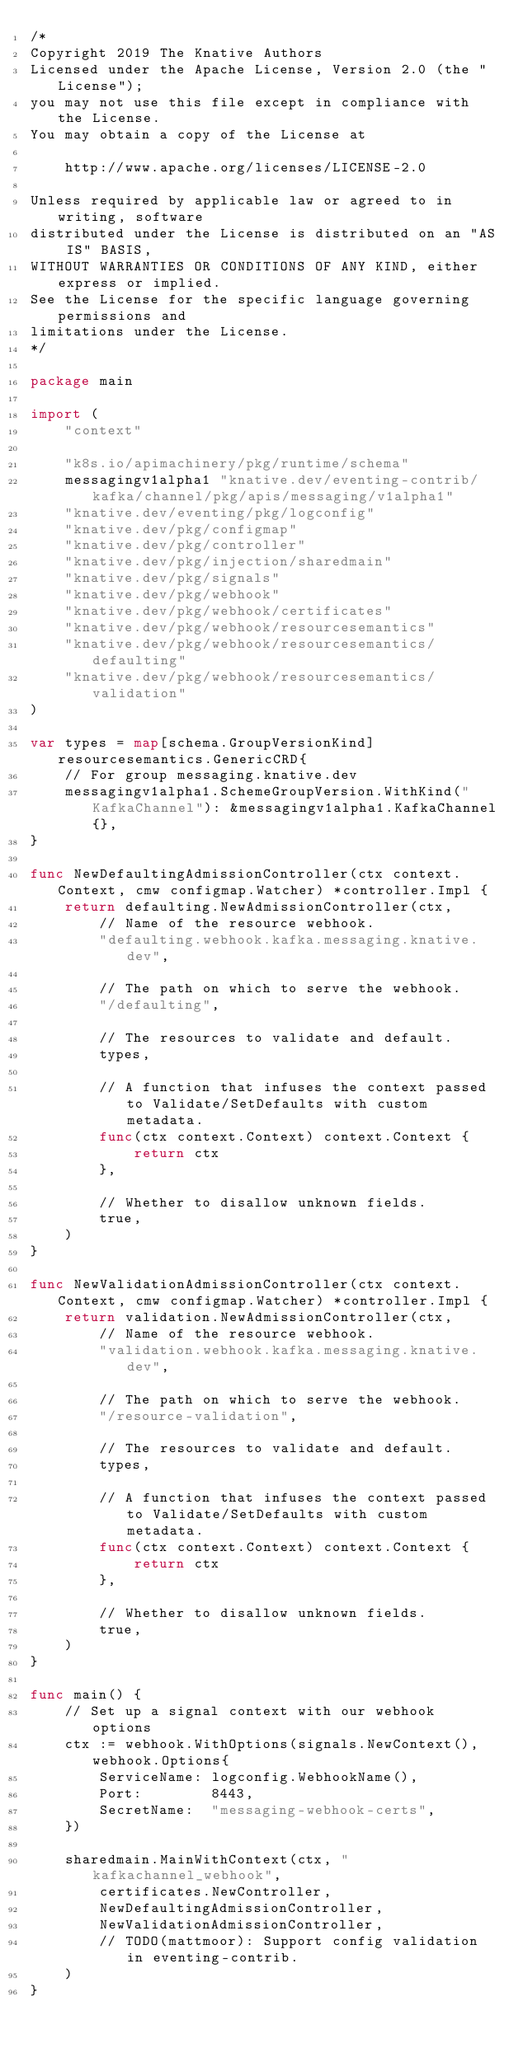Convert code to text. <code><loc_0><loc_0><loc_500><loc_500><_Go_>/*
Copyright 2019 The Knative Authors
Licensed under the Apache License, Version 2.0 (the "License");
you may not use this file except in compliance with the License.
You may obtain a copy of the License at

    http://www.apache.org/licenses/LICENSE-2.0

Unless required by applicable law or agreed to in writing, software
distributed under the License is distributed on an "AS IS" BASIS,
WITHOUT WARRANTIES OR CONDITIONS OF ANY KIND, either express or implied.
See the License for the specific language governing permissions and
limitations under the License.
*/

package main

import (
	"context"

	"k8s.io/apimachinery/pkg/runtime/schema"
	messagingv1alpha1 "knative.dev/eventing-contrib/kafka/channel/pkg/apis/messaging/v1alpha1"
	"knative.dev/eventing/pkg/logconfig"
	"knative.dev/pkg/configmap"
	"knative.dev/pkg/controller"
	"knative.dev/pkg/injection/sharedmain"
	"knative.dev/pkg/signals"
	"knative.dev/pkg/webhook"
	"knative.dev/pkg/webhook/certificates"
	"knative.dev/pkg/webhook/resourcesemantics"
	"knative.dev/pkg/webhook/resourcesemantics/defaulting"
	"knative.dev/pkg/webhook/resourcesemantics/validation"
)

var types = map[schema.GroupVersionKind]resourcesemantics.GenericCRD{
	// For group messaging.knative.dev
	messagingv1alpha1.SchemeGroupVersion.WithKind("KafkaChannel"): &messagingv1alpha1.KafkaChannel{},
}

func NewDefaultingAdmissionController(ctx context.Context, cmw configmap.Watcher) *controller.Impl {
	return defaulting.NewAdmissionController(ctx,
		// Name of the resource webhook.
		"defaulting.webhook.kafka.messaging.knative.dev",

		// The path on which to serve the webhook.
		"/defaulting",

		// The resources to validate and default.
		types,

		// A function that infuses the context passed to Validate/SetDefaults with custom metadata.
		func(ctx context.Context) context.Context {
			return ctx
		},

		// Whether to disallow unknown fields.
		true,
	)
}

func NewValidationAdmissionController(ctx context.Context, cmw configmap.Watcher) *controller.Impl {
	return validation.NewAdmissionController(ctx,
		// Name of the resource webhook.
		"validation.webhook.kafka.messaging.knative.dev",

		// The path on which to serve the webhook.
		"/resource-validation",

		// The resources to validate and default.
		types,

		// A function that infuses the context passed to Validate/SetDefaults with custom metadata.
		func(ctx context.Context) context.Context {
			return ctx
		},

		// Whether to disallow unknown fields.
		true,
	)
}

func main() {
	// Set up a signal context with our webhook options
	ctx := webhook.WithOptions(signals.NewContext(), webhook.Options{
		ServiceName: logconfig.WebhookName(),
		Port:        8443,
		SecretName:  "messaging-webhook-certs",
	})

	sharedmain.MainWithContext(ctx, "kafkachannel_webhook",
		certificates.NewController,
		NewDefaultingAdmissionController,
		NewValidationAdmissionController,
		// TODO(mattmoor): Support config validation in eventing-contrib.
	)
}
</code> 